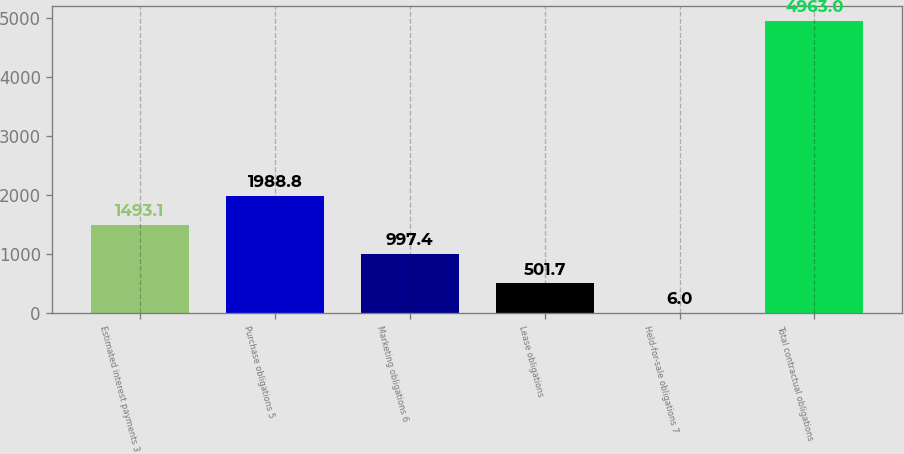Convert chart to OTSL. <chart><loc_0><loc_0><loc_500><loc_500><bar_chart><fcel>Estimated interest payments 3<fcel>Purchase obligations 5<fcel>Marketing obligations 6<fcel>Lease obligations<fcel>Held-for-sale obligations 7<fcel>Total contractual obligations<nl><fcel>1493.1<fcel>1988.8<fcel>997.4<fcel>501.7<fcel>6<fcel>4963<nl></chart> 